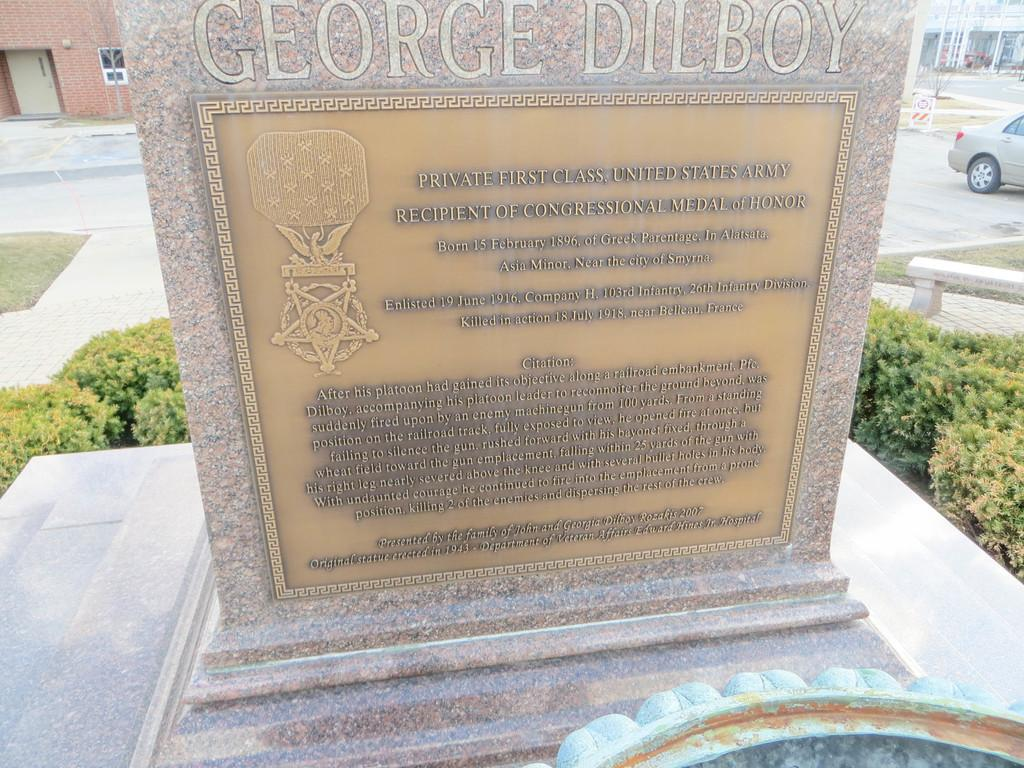What is the main object in the image? There is a headstone in the image. What can be found on the headstone? There is text on the headstone. What is present around the headstone? There are plants around the headstone. What can be seen in the distance in the image? There are buildings and a car in the background of the image. What type of throne is depicted on the headstone? There is no throne present on the headstone; it is a headstone with text and surrounded by plants. Is there a crown visible on the headstone? There is no crown present on the headstone; it is a headstone with text and surrounded by plants. 